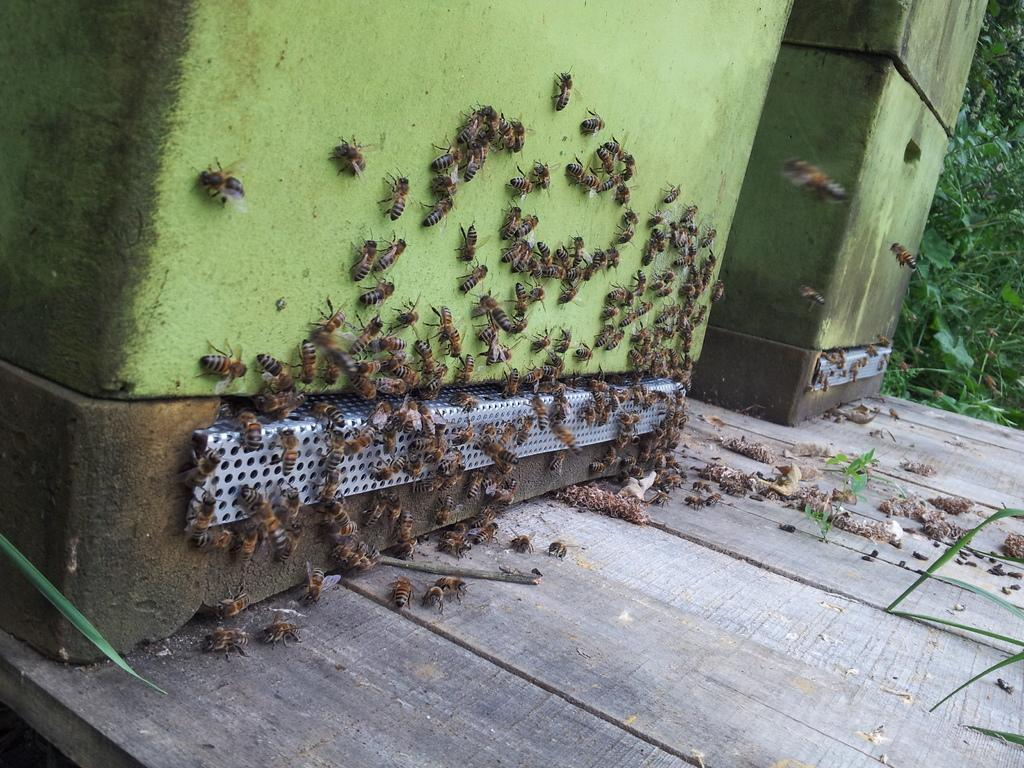What objects are present in the image that can hold items? There are containers in the image. What type of insects can be seen in the image? There are honey-bees in the image. What material is the surface on which the containers and honey-bees are placed? There is a wooden surface in the image. What type of vegetation is visible in the image? There are plants in the image. How many trees are present in the image? There are no trees visible in the image. What type of branch can be seen in the image? There is no branch present in the image. 